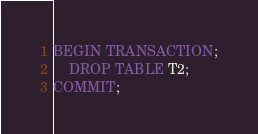<code> <loc_0><loc_0><loc_500><loc_500><_SQL_>BEGIN TRANSACTION;
    DROP TABLE T2;
COMMIT;
</code> 